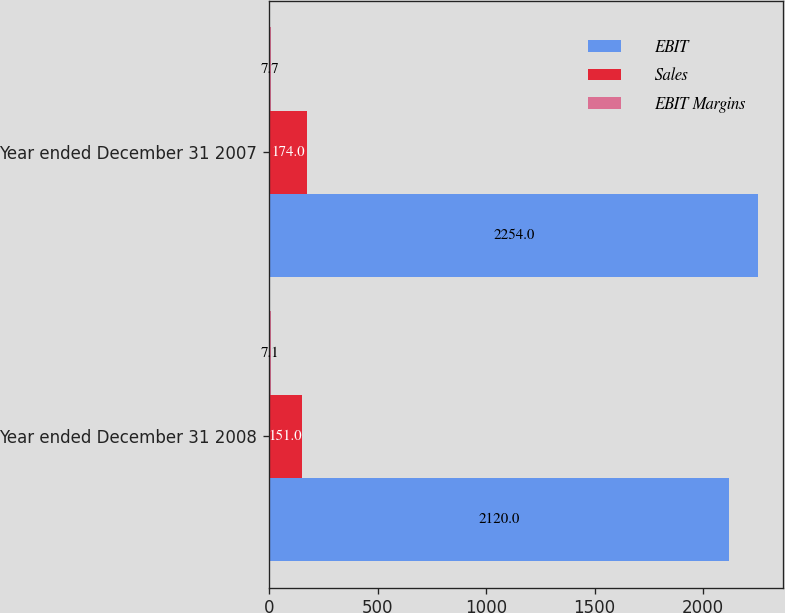Convert chart to OTSL. <chart><loc_0><loc_0><loc_500><loc_500><stacked_bar_chart><ecel><fcel>Year ended December 31 2008<fcel>Year ended December 31 2007<nl><fcel>EBIT<fcel>2120<fcel>2254<nl><fcel>Sales<fcel>151<fcel>174<nl><fcel>EBIT Margins<fcel>7.1<fcel>7.7<nl></chart> 